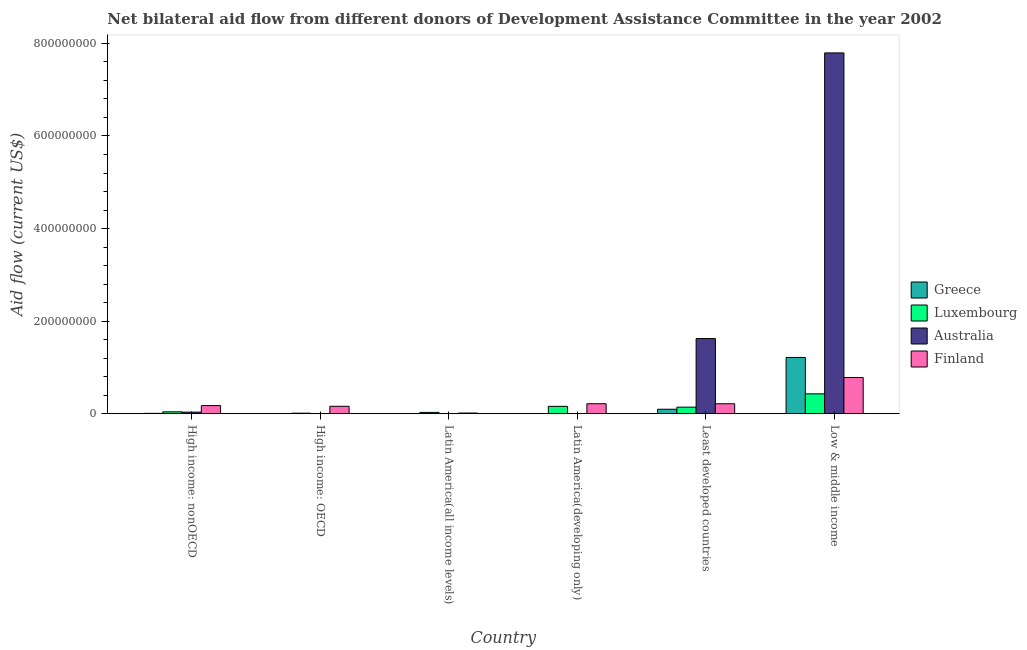How many different coloured bars are there?
Your response must be concise. 4. Are the number of bars per tick equal to the number of legend labels?
Your response must be concise. Yes. What is the label of the 1st group of bars from the left?
Your response must be concise. High income: nonOECD. What is the amount of aid given by luxembourg in High income: nonOECD?
Your answer should be very brief. 4.10e+06. Across all countries, what is the maximum amount of aid given by luxembourg?
Provide a short and direct response. 4.30e+07. Across all countries, what is the minimum amount of aid given by finland?
Your answer should be compact. 1.51e+06. In which country was the amount of aid given by greece minimum?
Offer a terse response. Latin America(developing only). What is the total amount of aid given by finland in the graph?
Provide a short and direct response. 1.57e+08. What is the difference between the amount of aid given by australia in Latin America(all income levels) and that in Low & middle income?
Make the answer very short. -7.79e+08. What is the difference between the amount of aid given by greece in Low & middle income and the amount of aid given by finland in Least developed countries?
Provide a succinct answer. 1.00e+08. What is the average amount of aid given by luxembourg per country?
Your answer should be very brief. 1.36e+07. What is the difference between the amount of aid given by luxembourg and amount of aid given by australia in Latin America(developing only)?
Your answer should be compact. 1.56e+07. In how many countries, is the amount of aid given by australia greater than 760000000 US$?
Your response must be concise. 1. What is the ratio of the amount of aid given by greece in High income: OECD to that in Low & middle income?
Give a very brief answer. 0. Is the amount of aid given by luxembourg in High income: OECD less than that in High income: nonOECD?
Provide a short and direct response. Yes. What is the difference between the highest and the second highest amount of aid given by greece?
Offer a very short reply. 1.12e+08. What is the difference between the highest and the lowest amount of aid given by australia?
Offer a very short reply. 7.79e+08. In how many countries, is the amount of aid given by finland greater than the average amount of aid given by finland taken over all countries?
Your response must be concise. 1. Is it the case that in every country, the sum of the amount of aid given by australia and amount of aid given by finland is greater than the sum of amount of aid given by luxembourg and amount of aid given by greece?
Offer a terse response. No. What does the 2nd bar from the left in Low & middle income represents?
Keep it short and to the point. Luxembourg. Is it the case that in every country, the sum of the amount of aid given by greece and amount of aid given by luxembourg is greater than the amount of aid given by australia?
Your answer should be compact. No. How many countries are there in the graph?
Give a very brief answer. 6. What is the difference between two consecutive major ticks on the Y-axis?
Your answer should be very brief. 2.00e+08. Are the values on the major ticks of Y-axis written in scientific E-notation?
Make the answer very short. No. Does the graph contain grids?
Give a very brief answer. No. Where does the legend appear in the graph?
Make the answer very short. Center right. How many legend labels are there?
Offer a terse response. 4. What is the title of the graph?
Your response must be concise. Net bilateral aid flow from different donors of Development Assistance Committee in the year 2002. Does "Fourth 20% of population" appear as one of the legend labels in the graph?
Provide a succinct answer. No. What is the label or title of the X-axis?
Make the answer very short. Country. What is the label or title of the Y-axis?
Keep it short and to the point. Aid flow (current US$). What is the Aid flow (current US$) in Greece in High income: nonOECD?
Your answer should be very brief. 8.20e+05. What is the Aid flow (current US$) of Luxembourg in High income: nonOECD?
Your response must be concise. 4.10e+06. What is the Aid flow (current US$) of Australia in High income: nonOECD?
Make the answer very short. 3.45e+06. What is the Aid flow (current US$) in Finland in High income: nonOECD?
Make the answer very short. 1.76e+07. What is the Aid flow (current US$) of Luxembourg in High income: OECD?
Provide a short and direct response. 1.22e+06. What is the Aid flow (current US$) in Finland in High income: OECD?
Your answer should be very brief. 1.61e+07. What is the Aid flow (current US$) in Luxembourg in Latin America(all income levels)?
Ensure brevity in your answer.  2.88e+06. What is the Aid flow (current US$) in Finland in Latin America(all income levels)?
Offer a very short reply. 1.51e+06. What is the Aid flow (current US$) of Greece in Latin America(developing only)?
Keep it short and to the point. 1.70e+05. What is the Aid flow (current US$) in Luxembourg in Latin America(developing only)?
Offer a terse response. 1.60e+07. What is the Aid flow (current US$) of Finland in Latin America(developing only)?
Ensure brevity in your answer.  2.16e+07. What is the Aid flow (current US$) of Greece in Least developed countries?
Provide a short and direct response. 9.70e+06. What is the Aid flow (current US$) of Luxembourg in Least developed countries?
Your response must be concise. 1.42e+07. What is the Aid flow (current US$) of Australia in Least developed countries?
Your answer should be compact. 1.62e+08. What is the Aid flow (current US$) in Finland in Least developed countries?
Offer a very short reply. 2.16e+07. What is the Aid flow (current US$) in Greece in Low & middle income?
Make the answer very short. 1.22e+08. What is the Aid flow (current US$) of Luxembourg in Low & middle income?
Your answer should be compact. 4.30e+07. What is the Aid flow (current US$) in Australia in Low & middle income?
Your response must be concise. 7.79e+08. What is the Aid flow (current US$) in Finland in Low & middle income?
Make the answer very short. 7.83e+07. Across all countries, what is the maximum Aid flow (current US$) in Greece?
Your response must be concise. 1.22e+08. Across all countries, what is the maximum Aid flow (current US$) of Luxembourg?
Make the answer very short. 4.30e+07. Across all countries, what is the maximum Aid flow (current US$) of Australia?
Give a very brief answer. 7.79e+08. Across all countries, what is the maximum Aid flow (current US$) in Finland?
Keep it short and to the point. 7.83e+07. Across all countries, what is the minimum Aid flow (current US$) of Luxembourg?
Keep it short and to the point. 1.22e+06. Across all countries, what is the minimum Aid flow (current US$) of Finland?
Offer a very short reply. 1.51e+06. What is the total Aid flow (current US$) of Greece in the graph?
Provide a short and direct response. 1.33e+08. What is the total Aid flow (current US$) in Luxembourg in the graph?
Ensure brevity in your answer.  8.14e+07. What is the total Aid flow (current US$) in Australia in the graph?
Your answer should be compact. 9.46e+08. What is the total Aid flow (current US$) of Finland in the graph?
Provide a short and direct response. 1.57e+08. What is the difference between the Aid flow (current US$) in Greece in High income: nonOECD and that in High income: OECD?
Offer a terse response. 3.60e+05. What is the difference between the Aid flow (current US$) in Luxembourg in High income: nonOECD and that in High income: OECD?
Provide a succinct answer. 2.88e+06. What is the difference between the Aid flow (current US$) of Australia in High income: nonOECD and that in High income: OECD?
Your answer should be very brief. 3.21e+06. What is the difference between the Aid flow (current US$) of Finland in High income: nonOECD and that in High income: OECD?
Your answer should be compact. 1.51e+06. What is the difference between the Aid flow (current US$) in Greece in High income: nonOECD and that in Latin America(all income levels)?
Keep it short and to the point. 6.40e+05. What is the difference between the Aid flow (current US$) in Luxembourg in High income: nonOECD and that in Latin America(all income levels)?
Make the answer very short. 1.22e+06. What is the difference between the Aid flow (current US$) of Australia in High income: nonOECD and that in Latin America(all income levels)?
Your response must be concise. 3.08e+06. What is the difference between the Aid flow (current US$) of Finland in High income: nonOECD and that in Latin America(all income levels)?
Give a very brief answer. 1.61e+07. What is the difference between the Aid flow (current US$) of Greece in High income: nonOECD and that in Latin America(developing only)?
Your answer should be compact. 6.50e+05. What is the difference between the Aid flow (current US$) in Luxembourg in High income: nonOECD and that in Latin America(developing only)?
Make the answer very short. -1.19e+07. What is the difference between the Aid flow (current US$) of Australia in High income: nonOECD and that in Latin America(developing only)?
Your answer should be very brief. 3.09e+06. What is the difference between the Aid flow (current US$) in Finland in High income: nonOECD and that in Latin America(developing only)?
Give a very brief answer. -4.03e+06. What is the difference between the Aid flow (current US$) in Greece in High income: nonOECD and that in Least developed countries?
Make the answer very short. -8.88e+06. What is the difference between the Aid flow (current US$) in Luxembourg in High income: nonOECD and that in Least developed countries?
Provide a succinct answer. -1.01e+07. What is the difference between the Aid flow (current US$) in Australia in High income: nonOECD and that in Least developed countries?
Offer a very short reply. -1.59e+08. What is the difference between the Aid flow (current US$) of Finland in High income: nonOECD and that in Least developed countries?
Offer a terse response. -3.97e+06. What is the difference between the Aid flow (current US$) of Greece in High income: nonOECD and that in Low & middle income?
Ensure brevity in your answer.  -1.21e+08. What is the difference between the Aid flow (current US$) in Luxembourg in High income: nonOECD and that in Low & middle income?
Your response must be concise. -3.89e+07. What is the difference between the Aid flow (current US$) in Australia in High income: nonOECD and that in Low & middle income?
Provide a succinct answer. -7.76e+08. What is the difference between the Aid flow (current US$) of Finland in High income: nonOECD and that in Low & middle income?
Provide a succinct answer. -6.07e+07. What is the difference between the Aid flow (current US$) of Luxembourg in High income: OECD and that in Latin America(all income levels)?
Offer a terse response. -1.66e+06. What is the difference between the Aid flow (current US$) of Finland in High income: OECD and that in Latin America(all income levels)?
Provide a succinct answer. 1.46e+07. What is the difference between the Aid flow (current US$) in Luxembourg in High income: OECD and that in Latin America(developing only)?
Make the answer very short. -1.48e+07. What is the difference between the Aid flow (current US$) in Australia in High income: OECD and that in Latin America(developing only)?
Ensure brevity in your answer.  -1.20e+05. What is the difference between the Aid flow (current US$) in Finland in High income: OECD and that in Latin America(developing only)?
Ensure brevity in your answer.  -5.54e+06. What is the difference between the Aid flow (current US$) in Greece in High income: OECD and that in Least developed countries?
Your answer should be very brief. -9.24e+06. What is the difference between the Aid flow (current US$) of Luxembourg in High income: OECD and that in Least developed countries?
Keep it short and to the point. -1.30e+07. What is the difference between the Aid flow (current US$) in Australia in High income: OECD and that in Least developed countries?
Give a very brief answer. -1.62e+08. What is the difference between the Aid flow (current US$) of Finland in High income: OECD and that in Least developed countries?
Ensure brevity in your answer.  -5.48e+06. What is the difference between the Aid flow (current US$) in Greece in High income: OECD and that in Low & middle income?
Your answer should be compact. -1.21e+08. What is the difference between the Aid flow (current US$) of Luxembourg in High income: OECD and that in Low & middle income?
Your response must be concise. -4.18e+07. What is the difference between the Aid flow (current US$) in Australia in High income: OECD and that in Low & middle income?
Your answer should be compact. -7.79e+08. What is the difference between the Aid flow (current US$) in Finland in High income: OECD and that in Low & middle income?
Your answer should be compact. -6.22e+07. What is the difference between the Aid flow (current US$) in Greece in Latin America(all income levels) and that in Latin America(developing only)?
Make the answer very short. 10000. What is the difference between the Aid flow (current US$) of Luxembourg in Latin America(all income levels) and that in Latin America(developing only)?
Your response must be concise. -1.31e+07. What is the difference between the Aid flow (current US$) of Australia in Latin America(all income levels) and that in Latin America(developing only)?
Ensure brevity in your answer.  10000. What is the difference between the Aid flow (current US$) of Finland in Latin America(all income levels) and that in Latin America(developing only)?
Offer a very short reply. -2.01e+07. What is the difference between the Aid flow (current US$) of Greece in Latin America(all income levels) and that in Least developed countries?
Ensure brevity in your answer.  -9.52e+06. What is the difference between the Aid flow (current US$) of Luxembourg in Latin America(all income levels) and that in Least developed countries?
Offer a terse response. -1.14e+07. What is the difference between the Aid flow (current US$) in Australia in Latin America(all income levels) and that in Least developed countries?
Provide a short and direct response. -1.62e+08. What is the difference between the Aid flow (current US$) of Finland in Latin America(all income levels) and that in Least developed countries?
Your answer should be compact. -2.01e+07. What is the difference between the Aid flow (current US$) of Greece in Latin America(all income levels) and that in Low & middle income?
Your answer should be compact. -1.21e+08. What is the difference between the Aid flow (current US$) of Luxembourg in Latin America(all income levels) and that in Low & middle income?
Ensure brevity in your answer.  -4.01e+07. What is the difference between the Aid flow (current US$) of Australia in Latin America(all income levels) and that in Low & middle income?
Your answer should be compact. -7.79e+08. What is the difference between the Aid flow (current US$) in Finland in Latin America(all income levels) and that in Low & middle income?
Your answer should be compact. -7.68e+07. What is the difference between the Aid flow (current US$) of Greece in Latin America(developing only) and that in Least developed countries?
Your response must be concise. -9.53e+06. What is the difference between the Aid flow (current US$) of Luxembourg in Latin America(developing only) and that in Least developed countries?
Offer a very short reply. 1.73e+06. What is the difference between the Aid flow (current US$) of Australia in Latin America(developing only) and that in Least developed countries?
Provide a succinct answer. -1.62e+08. What is the difference between the Aid flow (current US$) of Finland in Latin America(developing only) and that in Least developed countries?
Your response must be concise. 6.00e+04. What is the difference between the Aid flow (current US$) in Greece in Latin America(developing only) and that in Low & middle income?
Provide a short and direct response. -1.21e+08. What is the difference between the Aid flow (current US$) of Luxembourg in Latin America(developing only) and that in Low & middle income?
Your answer should be compact. -2.70e+07. What is the difference between the Aid flow (current US$) in Australia in Latin America(developing only) and that in Low & middle income?
Your answer should be compact. -7.79e+08. What is the difference between the Aid flow (current US$) of Finland in Latin America(developing only) and that in Low & middle income?
Keep it short and to the point. -5.67e+07. What is the difference between the Aid flow (current US$) in Greece in Least developed countries and that in Low & middle income?
Make the answer very short. -1.12e+08. What is the difference between the Aid flow (current US$) in Luxembourg in Least developed countries and that in Low & middle income?
Your response must be concise. -2.87e+07. What is the difference between the Aid flow (current US$) in Australia in Least developed countries and that in Low & middle income?
Ensure brevity in your answer.  -6.17e+08. What is the difference between the Aid flow (current US$) of Finland in Least developed countries and that in Low & middle income?
Your response must be concise. -5.67e+07. What is the difference between the Aid flow (current US$) in Greece in High income: nonOECD and the Aid flow (current US$) in Luxembourg in High income: OECD?
Your answer should be very brief. -4.00e+05. What is the difference between the Aid flow (current US$) of Greece in High income: nonOECD and the Aid flow (current US$) of Australia in High income: OECD?
Keep it short and to the point. 5.80e+05. What is the difference between the Aid flow (current US$) in Greece in High income: nonOECD and the Aid flow (current US$) in Finland in High income: OECD?
Provide a succinct answer. -1.53e+07. What is the difference between the Aid flow (current US$) in Luxembourg in High income: nonOECD and the Aid flow (current US$) in Australia in High income: OECD?
Your answer should be very brief. 3.86e+06. What is the difference between the Aid flow (current US$) of Luxembourg in High income: nonOECD and the Aid flow (current US$) of Finland in High income: OECD?
Offer a terse response. -1.20e+07. What is the difference between the Aid flow (current US$) of Australia in High income: nonOECD and the Aid flow (current US$) of Finland in High income: OECD?
Keep it short and to the point. -1.26e+07. What is the difference between the Aid flow (current US$) of Greece in High income: nonOECD and the Aid flow (current US$) of Luxembourg in Latin America(all income levels)?
Your response must be concise. -2.06e+06. What is the difference between the Aid flow (current US$) of Greece in High income: nonOECD and the Aid flow (current US$) of Australia in Latin America(all income levels)?
Offer a terse response. 4.50e+05. What is the difference between the Aid flow (current US$) in Greece in High income: nonOECD and the Aid flow (current US$) in Finland in Latin America(all income levels)?
Offer a terse response. -6.90e+05. What is the difference between the Aid flow (current US$) in Luxembourg in High income: nonOECD and the Aid flow (current US$) in Australia in Latin America(all income levels)?
Provide a succinct answer. 3.73e+06. What is the difference between the Aid flow (current US$) in Luxembourg in High income: nonOECD and the Aid flow (current US$) in Finland in Latin America(all income levels)?
Offer a very short reply. 2.59e+06. What is the difference between the Aid flow (current US$) in Australia in High income: nonOECD and the Aid flow (current US$) in Finland in Latin America(all income levels)?
Your response must be concise. 1.94e+06. What is the difference between the Aid flow (current US$) of Greece in High income: nonOECD and the Aid flow (current US$) of Luxembourg in Latin America(developing only)?
Offer a terse response. -1.52e+07. What is the difference between the Aid flow (current US$) in Greece in High income: nonOECD and the Aid flow (current US$) in Australia in Latin America(developing only)?
Your response must be concise. 4.60e+05. What is the difference between the Aid flow (current US$) in Greece in High income: nonOECD and the Aid flow (current US$) in Finland in Latin America(developing only)?
Your answer should be compact. -2.08e+07. What is the difference between the Aid flow (current US$) of Luxembourg in High income: nonOECD and the Aid flow (current US$) of Australia in Latin America(developing only)?
Give a very brief answer. 3.74e+06. What is the difference between the Aid flow (current US$) of Luxembourg in High income: nonOECD and the Aid flow (current US$) of Finland in Latin America(developing only)?
Keep it short and to the point. -1.75e+07. What is the difference between the Aid flow (current US$) of Australia in High income: nonOECD and the Aid flow (current US$) of Finland in Latin America(developing only)?
Provide a short and direct response. -1.82e+07. What is the difference between the Aid flow (current US$) of Greece in High income: nonOECD and the Aid flow (current US$) of Luxembourg in Least developed countries?
Your response must be concise. -1.34e+07. What is the difference between the Aid flow (current US$) in Greece in High income: nonOECD and the Aid flow (current US$) in Australia in Least developed countries?
Keep it short and to the point. -1.62e+08. What is the difference between the Aid flow (current US$) of Greece in High income: nonOECD and the Aid flow (current US$) of Finland in Least developed countries?
Make the answer very short. -2.08e+07. What is the difference between the Aid flow (current US$) of Luxembourg in High income: nonOECD and the Aid flow (current US$) of Australia in Least developed countries?
Give a very brief answer. -1.58e+08. What is the difference between the Aid flow (current US$) of Luxembourg in High income: nonOECD and the Aid flow (current US$) of Finland in Least developed countries?
Provide a succinct answer. -1.75e+07. What is the difference between the Aid flow (current US$) of Australia in High income: nonOECD and the Aid flow (current US$) of Finland in Least developed countries?
Your response must be concise. -1.81e+07. What is the difference between the Aid flow (current US$) in Greece in High income: nonOECD and the Aid flow (current US$) in Luxembourg in Low & middle income?
Your response must be concise. -4.22e+07. What is the difference between the Aid flow (current US$) of Greece in High income: nonOECD and the Aid flow (current US$) of Australia in Low & middle income?
Your answer should be compact. -7.79e+08. What is the difference between the Aid flow (current US$) of Greece in High income: nonOECD and the Aid flow (current US$) of Finland in Low & middle income?
Your answer should be compact. -7.75e+07. What is the difference between the Aid flow (current US$) of Luxembourg in High income: nonOECD and the Aid flow (current US$) of Australia in Low & middle income?
Your answer should be compact. -7.75e+08. What is the difference between the Aid flow (current US$) of Luxembourg in High income: nonOECD and the Aid flow (current US$) of Finland in Low & middle income?
Give a very brief answer. -7.42e+07. What is the difference between the Aid flow (current US$) of Australia in High income: nonOECD and the Aid flow (current US$) of Finland in Low & middle income?
Ensure brevity in your answer.  -7.49e+07. What is the difference between the Aid flow (current US$) in Greece in High income: OECD and the Aid flow (current US$) in Luxembourg in Latin America(all income levels)?
Make the answer very short. -2.42e+06. What is the difference between the Aid flow (current US$) in Greece in High income: OECD and the Aid flow (current US$) in Finland in Latin America(all income levels)?
Your answer should be compact. -1.05e+06. What is the difference between the Aid flow (current US$) in Luxembourg in High income: OECD and the Aid flow (current US$) in Australia in Latin America(all income levels)?
Your answer should be compact. 8.50e+05. What is the difference between the Aid flow (current US$) in Luxembourg in High income: OECD and the Aid flow (current US$) in Finland in Latin America(all income levels)?
Keep it short and to the point. -2.90e+05. What is the difference between the Aid flow (current US$) of Australia in High income: OECD and the Aid flow (current US$) of Finland in Latin America(all income levels)?
Offer a terse response. -1.27e+06. What is the difference between the Aid flow (current US$) of Greece in High income: OECD and the Aid flow (current US$) of Luxembourg in Latin America(developing only)?
Offer a very short reply. -1.55e+07. What is the difference between the Aid flow (current US$) in Greece in High income: OECD and the Aid flow (current US$) in Finland in Latin America(developing only)?
Give a very brief answer. -2.12e+07. What is the difference between the Aid flow (current US$) in Luxembourg in High income: OECD and the Aid flow (current US$) in Australia in Latin America(developing only)?
Ensure brevity in your answer.  8.60e+05. What is the difference between the Aid flow (current US$) of Luxembourg in High income: OECD and the Aid flow (current US$) of Finland in Latin America(developing only)?
Provide a short and direct response. -2.04e+07. What is the difference between the Aid flow (current US$) in Australia in High income: OECD and the Aid flow (current US$) in Finland in Latin America(developing only)?
Your response must be concise. -2.14e+07. What is the difference between the Aid flow (current US$) of Greece in High income: OECD and the Aid flow (current US$) of Luxembourg in Least developed countries?
Offer a terse response. -1.38e+07. What is the difference between the Aid flow (current US$) of Greece in High income: OECD and the Aid flow (current US$) of Australia in Least developed countries?
Provide a succinct answer. -1.62e+08. What is the difference between the Aid flow (current US$) of Greece in High income: OECD and the Aid flow (current US$) of Finland in Least developed countries?
Your answer should be very brief. -2.11e+07. What is the difference between the Aid flow (current US$) of Luxembourg in High income: OECD and the Aid flow (current US$) of Australia in Least developed countries?
Provide a succinct answer. -1.61e+08. What is the difference between the Aid flow (current US$) in Luxembourg in High income: OECD and the Aid flow (current US$) in Finland in Least developed countries?
Keep it short and to the point. -2.04e+07. What is the difference between the Aid flow (current US$) in Australia in High income: OECD and the Aid flow (current US$) in Finland in Least developed countries?
Offer a terse response. -2.13e+07. What is the difference between the Aid flow (current US$) of Greece in High income: OECD and the Aid flow (current US$) of Luxembourg in Low & middle income?
Give a very brief answer. -4.25e+07. What is the difference between the Aid flow (current US$) of Greece in High income: OECD and the Aid flow (current US$) of Australia in Low & middle income?
Make the answer very short. -7.79e+08. What is the difference between the Aid flow (current US$) in Greece in High income: OECD and the Aid flow (current US$) in Finland in Low & middle income?
Keep it short and to the point. -7.78e+07. What is the difference between the Aid flow (current US$) of Luxembourg in High income: OECD and the Aid flow (current US$) of Australia in Low & middle income?
Provide a short and direct response. -7.78e+08. What is the difference between the Aid flow (current US$) in Luxembourg in High income: OECD and the Aid flow (current US$) in Finland in Low & middle income?
Provide a short and direct response. -7.71e+07. What is the difference between the Aid flow (current US$) in Australia in High income: OECD and the Aid flow (current US$) in Finland in Low & middle income?
Make the answer very short. -7.81e+07. What is the difference between the Aid flow (current US$) in Greece in Latin America(all income levels) and the Aid flow (current US$) in Luxembourg in Latin America(developing only)?
Your answer should be compact. -1.58e+07. What is the difference between the Aid flow (current US$) in Greece in Latin America(all income levels) and the Aid flow (current US$) in Finland in Latin America(developing only)?
Provide a succinct answer. -2.14e+07. What is the difference between the Aid flow (current US$) of Luxembourg in Latin America(all income levels) and the Aid flow (current US$) of Australia in Latin America(developing only)?
Offer a very short reply. 2.52e+06. What is the difference between the Aid flow (current US$) in Luxembourg in Latin America(all income levels) and the Aid flow (current US$) in Finland in Latin America(developing only)?
Provide a short and direct response. -1.88e+07. What is the difference between the Aid flow (current US$) of Australia in Latin America(all income levels) and the Aid flow (current US$) of Finland in Latin America(developing only)?
Provide a short and direct response. -2.13e+07. What is the difference between the Aid flow (current US$) in Greece in Latin America(all income levels) and the Aid flow (current US$) in Luxembourg in Least developed countries?
Provide a succinct answer. -1.41e+07. What is the difference between the Aid flow (current US$) of Greece in Latin America(all income levels) and the Aid flow (current US$) of Australia in Least developed countries?
Make the answer very short. -1.62e+08. What is the difference between the Aid flow (current US$) in Greece in Latin America(all income levels) and the Aid flow (current US$) in Finland in Least developed countries?
Make the answer very short. -2.14e+07. What is the difference between the Aid flow (current US$) of Luxembourg in Latin America(all income levels) and the Aid flow (current US$) of Australia in Least developed countries?
Offer a very short reply. -1.60e+08. What is the difference between the Aid flow (current US$) in Luxembourg in Latin America(all income levels) and the Aid flow (current US$) in Finland in Least developed countries?
Offer a terse response. -1.87e+07. What is the difference between the Aid flow (current US$) of Australia in Latin America(all income levels) and the Aid flow (current US$) of Finland in Least developed countries?
Ensure brevity in your answer.  -2.12e+07. What is the difference between the Aid flow (current US$) in Greece in Latin America(all income levels) and the Aid flow (current US$) in Luxembourg in Low & middle income?
Offer a terse response. -4.28e+07. What is the difference between the Aid flow (current US$) of Greece in Latin America(all income levels) and the Aid flow (current US$) of Australia in Low & middle income?
Ensure brevity in your answer.  -7.79e+08. What is the difference between the Aid flow (current US$) of Greece in Latin America(all income levels) and the Aid flow (current US$) of Finland in Low & middle income?
Keep it short and to the point. -7.81e+07. What is the difference between the Aid flow (current US$) in Luxembourg in Latin America(all income levels) and the Aid flow (current US$) in Australia in Low & middle income?
Your response must be concise. -7.77e+08. What is the difference between the Aid flow (current US$) of Luxembourg in Latin America(all income levels) and the Aid flow (current US$) of Finland in Low & middle income?
Offer a very short reply. -7.54e+07. What is the difference between the Aid flow (current US$) of Australia in Latin America(all income levels) and the Aid flow (current US$) of Finland in Low & middle income?
Offer a terse response. -7.79e+07. What is the difference between the Aid flow (current US$) of Greece in Latin America(developing only) and the Aid flow (current US$) of Luxembourg in Least developed countries?
Your answer should be compact. -1.41e+07. What is the difference between the Aid flow (current US$) in Greece in Latin America(developing only) and the Aid flow (current US$) in Australia in Least developed countries?
Your response must be concise. -1.62e+08. What is the difference between the Aid flow (current US$) of Greece in Latin America(developing only) and the Aid flow (current US$) of Finland in Least developed countries?
Provide a succinct answer. -2.14e+07. What is the difference between the Aid flow (current US$) of Luxembourg in Latin America(developing only) and the Aid flow (current US$) of Australia in Least developed countries?
Make the answer very short. -1.46e+08. What is the difference between the Aid flow (current US$) in Luxembourg in Latin America(developing only) and the Aid flow (current US$) in Finland in Least developed countries?
Offer a terse response. -5.60e+06. What is the difference between the Aid flow (current US$) in Australia in Latin America(developing only) and the Aid flow (current US$) in Finland in Least developed countries?
Offer a very short reply. -2.12e+07. What is the difference between the Aid flow (current US$) of Greece in Latin America(developing only) and the Aid flow (current US$) of Luxembourg in Low & middle income?
Offer a terse response. -4.28e+07. What is the difference between the Aid flow (current US$) in Greece in Latin America(developing only) and the Aid flow (current US$) in Australia in Low & middle income?
Keep it short and to the point. -7.79e+08. What is the difference between the Aid flow (current US$) in Greece in Latin America(developing only) and the Aid flow (current US$) in Finland in Low & middle income?
Your answer should be compact. -7.81e+07. What is the difference between the Aid flow (current US$) in Luxembourg in Latin America(developing only) and the Aid flow (current US$) in Australia in Low & middle income?
Offer a terse response. -7.63e+08. What is the difference between the Aid flow (current US$) of Luxembourg in Latin America(developing only) and the Aid flow (current US$) of Finland in Low & middle income?
Keep it short and to the point. -6.23e+07. What is the difference between the Aid flow (current US$) in Australia in Latin America(developing only) and the Aid flow (current US$) in Finland in Low & middle income?
Give a very brief answer. -7.80e+07. What is the difference between the Aid flow (current US$) in Greece in Least developed countries and the Aid flow (current US$) in Luxembourg in Low & middle income?
Give a very brief answer. -3.33e+07. What is the difference between the Aid flow (current US$) of Greece in Least developed countries and the Aid flow (current US$) of Australia in Low & middle income?
Offer a terse response. -7.70e+08. What is the difference between the Aid flow (current US$) in Greece in Least developed countries and the Aid flow (current US$) in Finland in Low & middle income?
Offer a terse response. -6.86e+07. What is the difference between the Aid flow (current US$) of Luxembourg in Least developed countries and the Aid flow (current US$) of Australia in Low & middle income?
Offer a very short reply. -7.65e+08. What is the difference between the Aid flow (current US$) of Luxembourg in Least developed countries and the Aid flow (current US$) of Finland in Low & middle income?
Keep it short and to the point. -6.41e+07. What is the difference between the Aid flow (current US$) in Australia in Least developed countries and the Aid flow (current US$) in Finland in Low & middle income?
Provide a short and direct response. 8.41e+07. What is the average Aid flow (current US$) of Greece per country?
Your response must be concise. 2.22e+07. What is the average Aid flow (current US$) of Luxembourg per country?
Provide a short and direct response. 1.36e+07. What is the average Aid flow (current US$) in Australia per country?
Provide a short and direct response. 1.58e+08. What is the average Aid flow (current US$) of Finland per country?
Your answer should be very brief. 2.61e+07. What is the difference between the Aid flow (current US$) of Greece and Aid flow (current US$) of Luxembourg in High income: nonOECD?
Your answer should be very brief. -3.28e+06. What is the difference between the Aid flow (current US$) of Greece and Aid flow (current US$) of Australia in High income: nonOECD?
Give a very brief answer. -2.63e+06. What is the difference between the Aid flow (current US$) of Greece and Aid flow (current US$) of Finland in High income: nonOECD?
Your answer should be compact. -1.68e+07. What is the difference between the Aid flow (current US$) in Luxembourg and Aid flow (current US$) in Australia in High income: nonOECD?
Provide a succinct answer. 6.50e+05. What is the difference between the Aid flow (current US$) of Luxembourg and Aid flow (current US$) of Finland in High income: nonOECD?
Your answer should be compact. -1.35e+07. What is the difference between the Aid flow (current US$) of Australia and Aid flow (current US$) of Finland in High income: nonOECD?
Provide a succinct answer. -1.42e+07. What is the difference between the Aid flow (current US$) of Greece and Aid flow (current US$) of Luxembourg in High income: OECD?
Provide a short and direct response. -7.60e+05. What is the difference between the Aid flow (current US$) in Greece and Aid flow (current US$) in Australia in High income: OECD?
Ensure brevity in your answer.  2.20e+05. What is the difference between the Aid flow (current US$) in Greece and Aid flow (current US$) in Finland in High income: OECD?
Make the answer very short. -1.56e+07. What is the difference between the Aid flow (current US$) of Luxembourg and Aid flow (current US$) of Australia in High income: OECD?
Provide a succinct answer. 9.80e+05. What is the difference between the Aid flow (current US$) in Luxembourg and Aid flow (current US$) in Finland in High income: OECD?
Offer a terse response. -1.49e+07. What is the difference between the Aid flow (current US$) in Australia and Aid flow (current US$) in Finland in High income: OECD?
Your answer should be compact. -1.58e+07. What is the difference between the Aid flow (current US$) in Greece and Aid flow (current US$) in Luxembourg in Latin America(all income levels)?
Offer a very short reply. -2.70e+06. What is the difference between the Aid flow (current US$) in Greece and Aid flow (current US$) in Finland in Latin America(all income levels)?
Offer a terse response. -1.33e+06. What is the difference between the Aid flow (current US$) of Luxembourg and Aid flow (current US$) of Australia in Latin America(all income levels)?
Your response must be concise. 2.51e+06. What is the difference between the Aid flow (current US$) in Luxembourg and Aid flow (current US$) in Finland in Latin America(all income levels)?
Ensure brevity in your answer.  1.37e+06. What is the difference between the Aid flow (current US$) of Australia and Aid flow (current US$) of Finland in Latin America(all income levels)?
Provide a succinct answer. -1.14e+06. What is the difference between the Aid flow (current US$) of Greece and Aid flow (current US$) of Luxembourg in Latin America(developing only)?
Your response must be concise. -1.58e+07. What is the difference between the Aid flow (current US$) of Greece and Aid flow (current US$) of Australia in Latin America(developing only)?
Make the answer very short. -1.90e+05. What is the difference between the Aid flow (current US$) in Greece and Aid flow (current US$) in Finland in Latin America(developing only)?
Keep it short and to the point. -2.15e+07. What is the difference between the Aid flow (current US$) of Luxembourg and Aid flow (current US$) of Australia in Latin America(developing only)?
Make the answer very short. 1.56e+07. What is the difference between the Aid flow (current US$) in Luxembourg and Aid flow (current US$) in Finland in Latin America(developing only)?
Your response must be concise. -5.66e+06. What is the difference between the Aid flow (current US$) of Australia and Aid flow (current US$) of Finland in Latin America(developing only)?
Your response must be concise. -2.13e+07. What is the difference between the Aid flow (current US$) in Greece and Aid flow (current US$) in Luxembourg in Least developed countries?
Make the answer very short. -4.54e+06. What is the difference between the Aid flow (current US$) in Greece and Aid flow (current US$) in Australia in Least developed countries?
Keep it short and to the point. -1.53e+08. What is the difference between the Aid flow (current US$) of Greece and Aid flow (current US$) of Finland in Least developed countries?
Provide a short and direct response. -1.19e+07. What is the difference between the Aid flow (current US$) in Luxembourg and Aid flow (current US$) in Australia in Least developed countries?
Your response must be concise. -1.48e+08. What is the difference between the Aid flow (current US$) in Luxembourg and Aid flow (current US$) in Finland in Least developed countries?
Give a very brief answer. -7.33e+06. What is the difference between the Aid flow (current US$) of Australia and Aid flow (current US$) of Finland in Least developed countries?
Your answer should be compact. 1.41e+08. What is the difference between the Aid flow (current US$) in Greece and Aid flow (current US$) in Luxembourg in Low & middle income?
Provide a short and direct response. 7.86e+07. What is the difference between the Aid flow (current US$) in Greece and Aid flow (current US$) in Australia in Low & middle income?
Make the answer very short. -6.58e+08. What is the difference between the Aid flow (current US$) in Greece and Aid flow (current US$) in Finland in Low & middle income?
Offer a terse response. 4.33e+07. What is the difference between the Aid flow (current US$) in Luxembourg and Aid flow (current US$) in Australia in Low & middle income?
Your answer should be compact. -7.36e+08. What is the difference between the Aid flow (current US$) in Luxembourg and Aid flow (current US$) in Finland in Low & middle income?
Offer a terse response. -3.53e+07. What is the difference between the Aid flow (current US$) of Australia and Aid flow (current US$) of Finland in Low & middle income?
Your answer should be compact. 7.01e+08. What is the ratio of the Aid flow (current US$) in Greece in High income: nonOECD to that in High income: OECD?
Give a very brief answer. 1.78. What is the ratio of the Aid flow (current US$) in Luxembourg in High income: nonOECD to that in High income: OECD?
Ensure brevity in your answer.  3.36. What is the ratio of the Aid flow (current US$) in Australia in High income: nonOECD to that in High income: OECD?
Your response must be concise. 14.38. What is the ratio of the Aid flow (current US$) in Finland in High income: nonOECD to that in High income: OECD?
Offer a very short reply. 1.09. What is the ratio of the Aid flow (current US$) in Greece in High income: nonOECD to that in Latin America(all income levels)?
Your response must be concise. 4.56. What is the ratio of the Aid flow (current US$) of Luxembourg in High income: nonOECD to that in Latin America(all income levels)?
Keep it short and to the point. 1.42. What is the ratio of the Aid flow (current US$) in Australia in High income: nonOECD to that in Latin America(all income levels)?
Provide a succinct answer. 9.32. What is the ratio of the Aid flow (current US$) of Finland in High income: nonOECD to that in Latin America(all income levels)?
Ensure brevity in your answer.  11.66. What is the ratio of the Aid flow (current US$) in Greece in High income: nonOECD to that in Latin America(developing only)?
Provide a short and direct response. 4.82. What is the ratio of the Aid flow (current US$) of Luxembourg in High income: nonOECD to that in Latin America(developing only)?
Give a very brief answer. 0.26. What is the ratio of the Aid flow (current US$) of Australia in High income: nonOECD to that in Latin America(developing only)?
Ensure brevity in your answer.  9.58. What is the ratio of the Aid flow (current US$) of Finland in High income: nonOECD to that in Latin America(developing only)?
Provide a short and direct response. 0.81. What is the ratio of the Aid flow (current US$) of Greece in High income: nonOECD to that in Least developed countries?
Ensure brevity in your answer.  0.08. What is the ratio of the Aid flow (current US$) of Luxembourg in High income: nonOECD to that in Least developed countries?
Make the answer very short. 0.29. What is the ratio of the Aid flow (current US$) in Australia in High income: nonOECD to that in Least developed countries?
Give a very brief answer. 0.02. What is the ratio of the Aid flow (current US$) of Finland in High income: nonOECD to that in Least developed countries?
Your answer should be compact. 0.82. What is the ratio of the Aid flow (current US$) in Greece in High income: nonOECD to that in Low & middle income?
Your response must be concise. 0.01. What is the ratio of the Aid flow (current US$) in Luxembourg in High income: nonOECD to that in Low & middle income?
Your answer should be compact. 0.1. What is the ratio of the Aid flow (current US$) in Australia in High income: nonOECD to that in Low & middle income?
Offer a very short reply. 0. What is the ratio of the Aid flow (current US$) of Finland in High income: nonOECD to that in Low & middle income?
Ensure brevity in your answer.  0.22. What is the ratio of the Aid flow (current US$) in Greece in High income: OECD to that in Latin America(all income levels)?
Offer a very short reply. 2.56. What is the ratio of the Aid flow (current US$) in Luxembourg in High income: OECD to that in Latin America(all income levels)?
Offer a terse response. 0.42. What is the ratio of the Aid flow (current US$) of Australia in High income: OECD to that in Latin America(all income levels)?
Your response must be concise. 0.65. What is the ratio of the Aid flow (current US$) in Finland in High income: OECD to that in Latin America(all income levels)?
Offer a terse response. 10.66. What is the ratio of the Aid flow (current US$) in Greece in High income: OECD to that in Latin America(developing only)?
Provide a short and direct response. 2.71. What is the ratio of the Aid flow (current US$) of Luxembourg in High income: OECD to that in Latin America(developing only)?
Provide a succinct answer. 0.08. What is the ratio of the Aid flow (current US$) of Australia in High income: OECD to that in Latin America(developing only)?
Provide a short and direct response. 0.67. What is the ratio of the Aid flow (current US$) in Finland in High income: OECD to that in Latin America(developing only)?
Ensure brevity in your answer.  0.74. What is the ratio of the Aid flow (current US$) of Greece in High income: OECD to that in Least developed countries?
Provide a short and direct response. 0.05. What is the ratio of the Aid flow (current US$) of Luxembourg in High income: OECD to that in Least developed countries?
Your answer should be very brief. 0.09. What is the ratio of the Aid flow (current US$) of Australia in High income: OECD to that in Least developed countries?
Offer a very short reply. 0. What is the ratio of the Aid flow (current US$) of Finland in High income: OECD to that in Least developed countries?
Your response must be concise. 0.75. What is the ratio of the Aid flow (current US$) in Greece in High income: OECD to that in Low & middle income?
Provide a succinct answer. 0. What is the ratio of the Aid flow (current US$) in Luxembourg in High income: OECD to that in Low & middle income?
Give a very brief answer. 0.03. What is the ratio of the Aid flow (current US$) in Australia in High income: OECD to that in Low & middle income?
Give a very brief answer. 0. What is the ratio of the Aid flow (current US$) in Finland in High income: OECD to that in Low & middle income?
Make the answer very short. 0.21. What is the ratio of the Aid flow (current US$) in Greece in Latin America(all income levels) to that in Latin America(developing only)?
Give a very brief answer. 1.06. What is the ratio of the Aid flow (current US$) in Luxembourg in Latin America(all income levels) to that in Latin America(developing only)?
Your response must be concise. 0.18. What is the ratio of the Aid flow (current US$) of Australia in Latin America(all income levels) to that in Latin America(developing only)?
Provide a succinct answer. 1.03. What is the ratio of the Aid flow (current US$) of Finland in Latin America(all income levels) to that in Latin America(developing only)?
Make the answer very short. 0.07. What is the ratio of the Aid flow (current US$) in Greece in Latin America(all income levels) to that in Least developed countries?
Your answer should be compact. 0.02. What is the ratio of the Aid flow (current US$) in Luxembourg in Latin America(all income levels) to that in Least developed countries?
Provide a succinct answer. 0.2. What is the ratio of the Aid flow (current US$) of Australia in Latin America(all income levels) to that in Least developed countries?
Your answer should be compact. 0. What is the ratio of the Aid flow (current US$) of Finland in Latin America(all income levels) to that in Least developed countries?
Keep it short and to the point. 0.07. What is the ratio of the Aid flow (current US$) in Greece in Latin America(all income levels) to that in Low & middle income?
Make the answer very short. 0. What is the ratio of the Aid flow (current US$) in Luxembourg in Latin America(all income levels) to that in Low & middle income?
Offer a terse response. 0.07. What is the ratio of the Aid flow (current US$) of Finland in Latin America(all income levels) to that in Low & middle income?
Give a very brief answer. 0.02. What is the ratio of the Aid flow (current US$) in Greece in Latin America(developing only) to that in Least developed countries?
Give a very brief answer. 0.02. What is the ratio of the Aid flow (current US$) of Luxembourg in Latin America(developing only) to that in Least developed countries?
Offer a very short reply. 1.12. What is the ratio of the Aid flow (current US$) of Australia in Latin America(developing only) to that in Least developed countries?
Offer a terse response. 0. What is the ratio of the Aid flow (current US$) in Finland in Latin America(developing only) to that in Least developed countries?
Offer a terse response. 1. What is the ratio of the Aid flow (current US$) in Greece in Latin America(developing only) to that in Low & middle income?
Keep it short and to the point. 0. What is the ratio of the Aid flow (current US$) in Luxembourg in Latin America(developing only) to that in Low & middle income?
Give a very brief answer. 0.37. What is the ratio of the Aid flow (current US$) of Finland in Latin America(developing only) to that in Low & middle income?
Keep it short and to the point. 0.28. What is the ratio of the Aid flow (current US$) of Greece in Least developed countries to that in Low & middle income?
Your answer should be very brief. 0.08. What is the ratio of the Aid flow (current US$) of Luxembourg in Least developed countries to that in Low & middle income?
Offer a very short reply. 0.33. What is the ratio of the Aid flow (current US$) of Australia in Least developed countries to that in Low & middle income?
Your answer should be compact. 0.21. What is the ratio of the Aid flow (current US$) in Finland in Least developed countries to that in Low & middle income?
Ensure brevity in your answer.  0.28. What is the difference between the highest and the second highest Aid flow (current US$) of Greece?
Your response must be concise. 1.12e+08. What is the difference between the highest and the second highest Aid flow (current US$) of Luxembourg?
Your answer should be compact. 2.70e+07. What is the difference between the highest and the second highest Aid flow (current US$) in Australia?
Provide a short and direct response. 6.17e+08. What is the difference between the highest and the second highest Aid flow (current US$) of Finland?
Your response must be concise. 5.67e+07. What is the difference between the highest and the lowest Aid flow (current US$) in Greece?
Offer a very short reply. 1.21e+08. What is the difference between the highest and the lowest Aid flow (current US$) of Luxembourg?
Provide a succinct answer. 4.18e+07. What is the difference between the highest and the lowest Aid flow (current US$) in Australia?
Provide a short and direct response. 7.79e+08. What is the difference between the highest and the lowest Aid flow (current US$) in Finland?
Provide a succinct answer. 7.68e+07. 